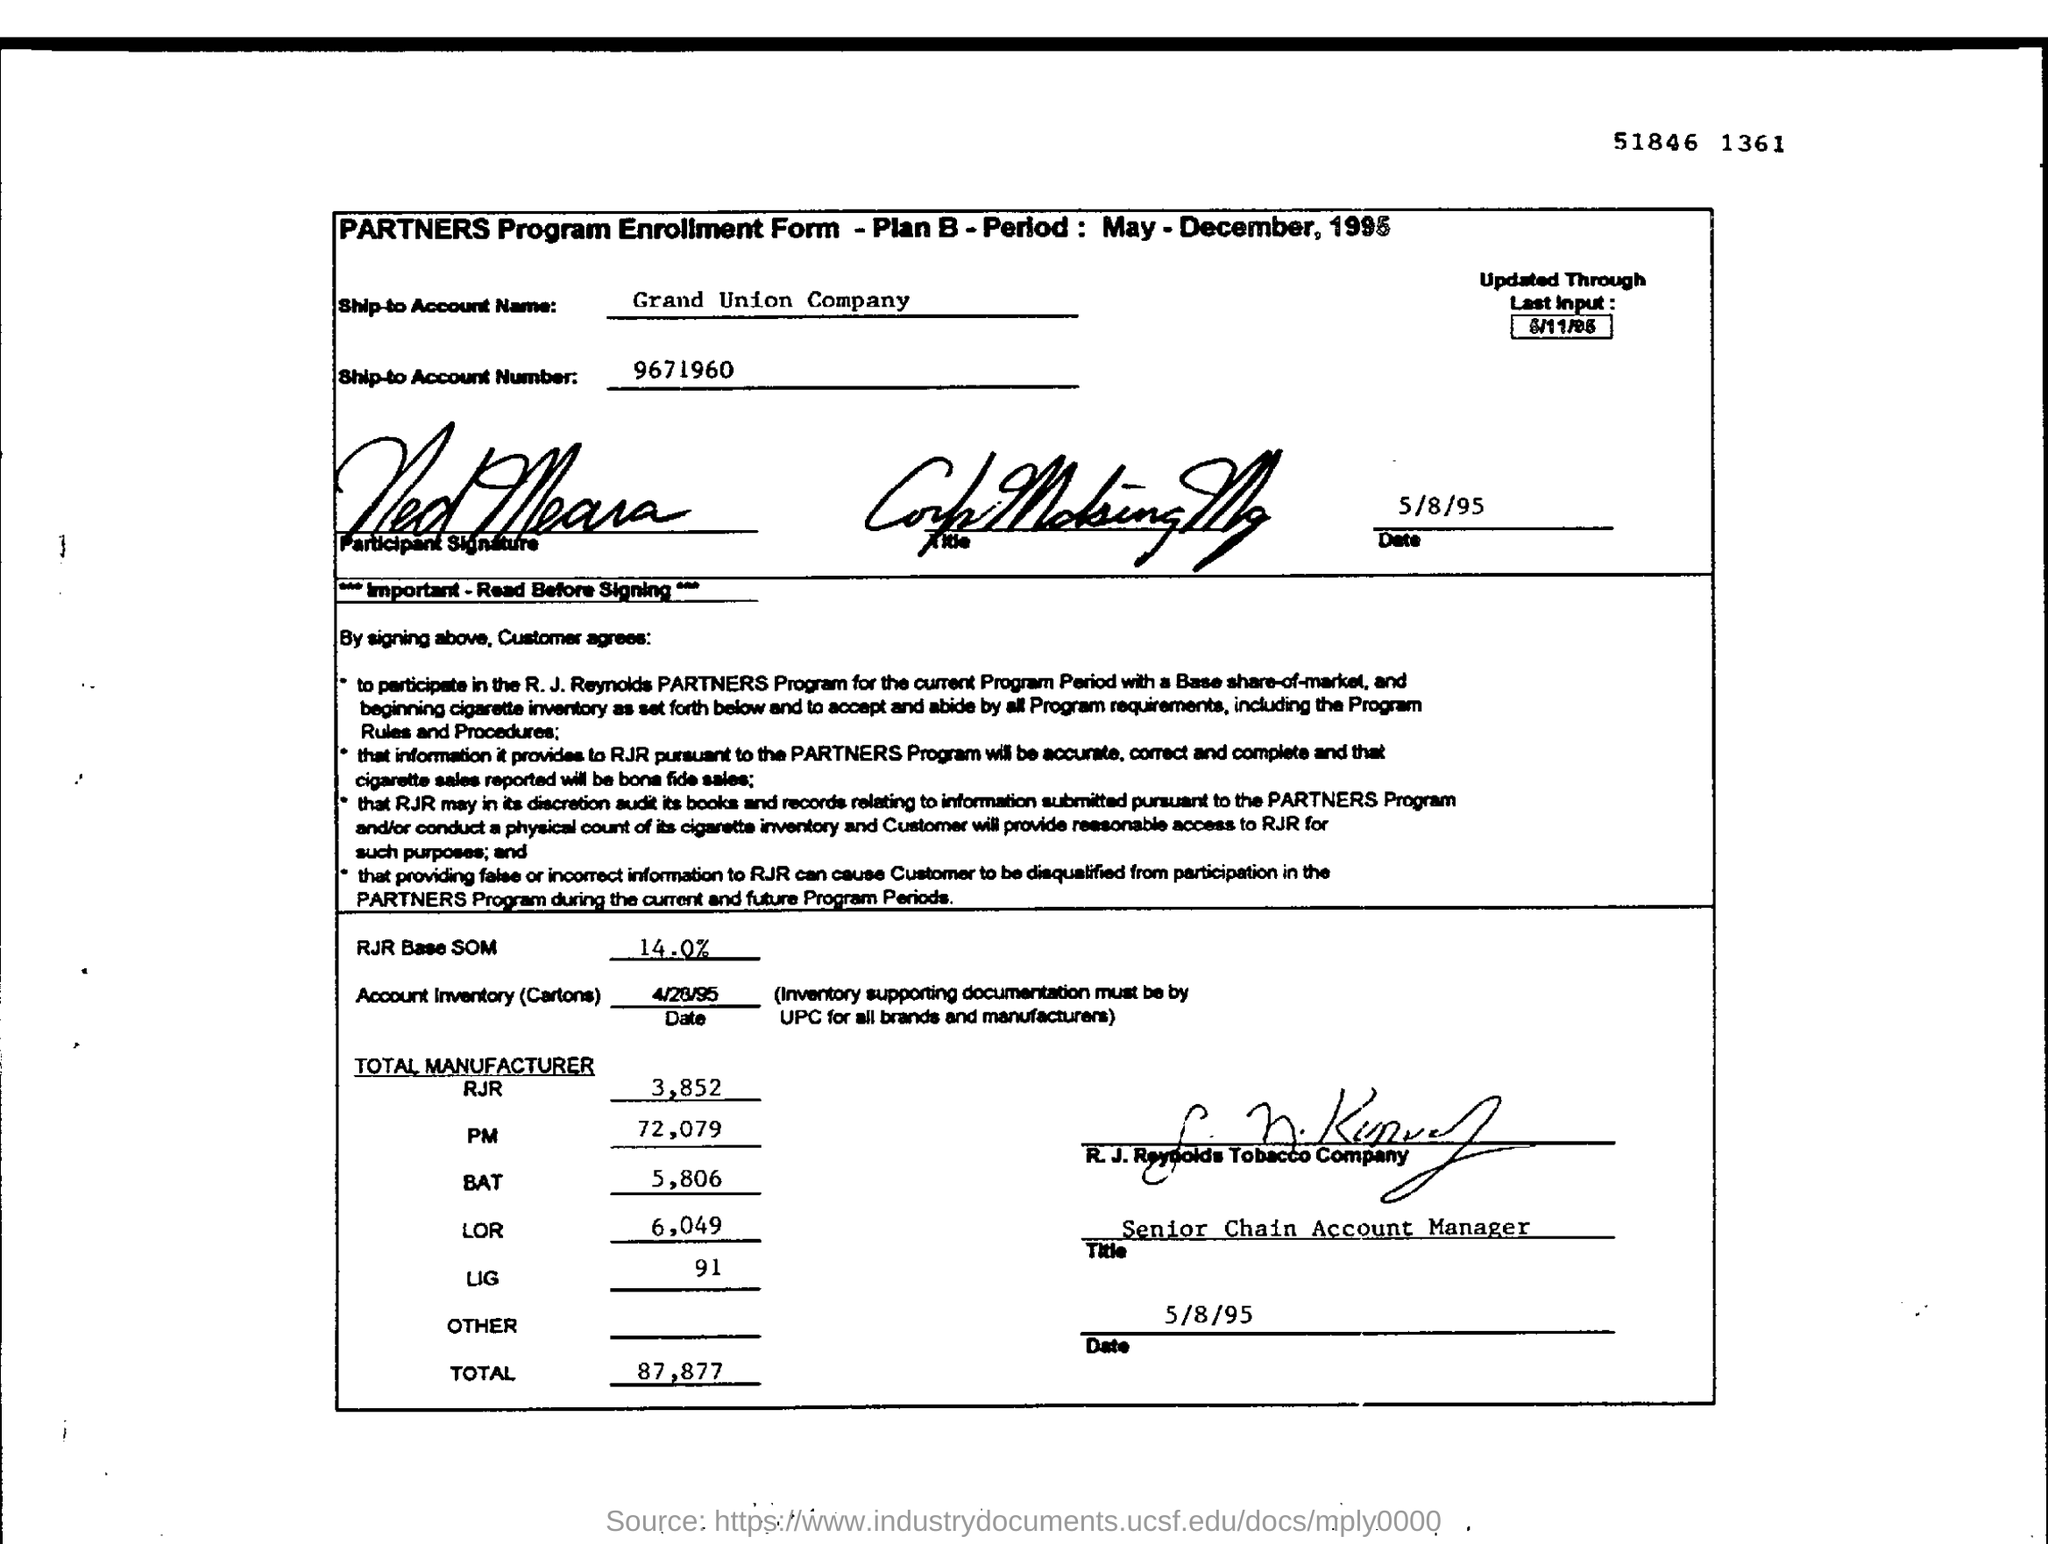What is the Ship-to Account Number?
Offer a very short reply. 9671960. What is the Ship-to Account Name?
Provide a short and direct response. Grand union company. What is the Total for Manufacturer "RJR"?
Your answer should be compact. 3,852. What is the Total for Manufacturer "BAT"?
Your answer should be compact. 5,806. What is the Total for Manufacturer "LIG"?
Give a very brief answer. 91. What is the Title?
Your answer should be compact. Senior Chain Account Manager. What is the Total for Manufacturer "PM"?
Give a very brief answer. 72,079. What is the Total for Manufacturer "LOR"?
Offer a very short reply. 6,049. 